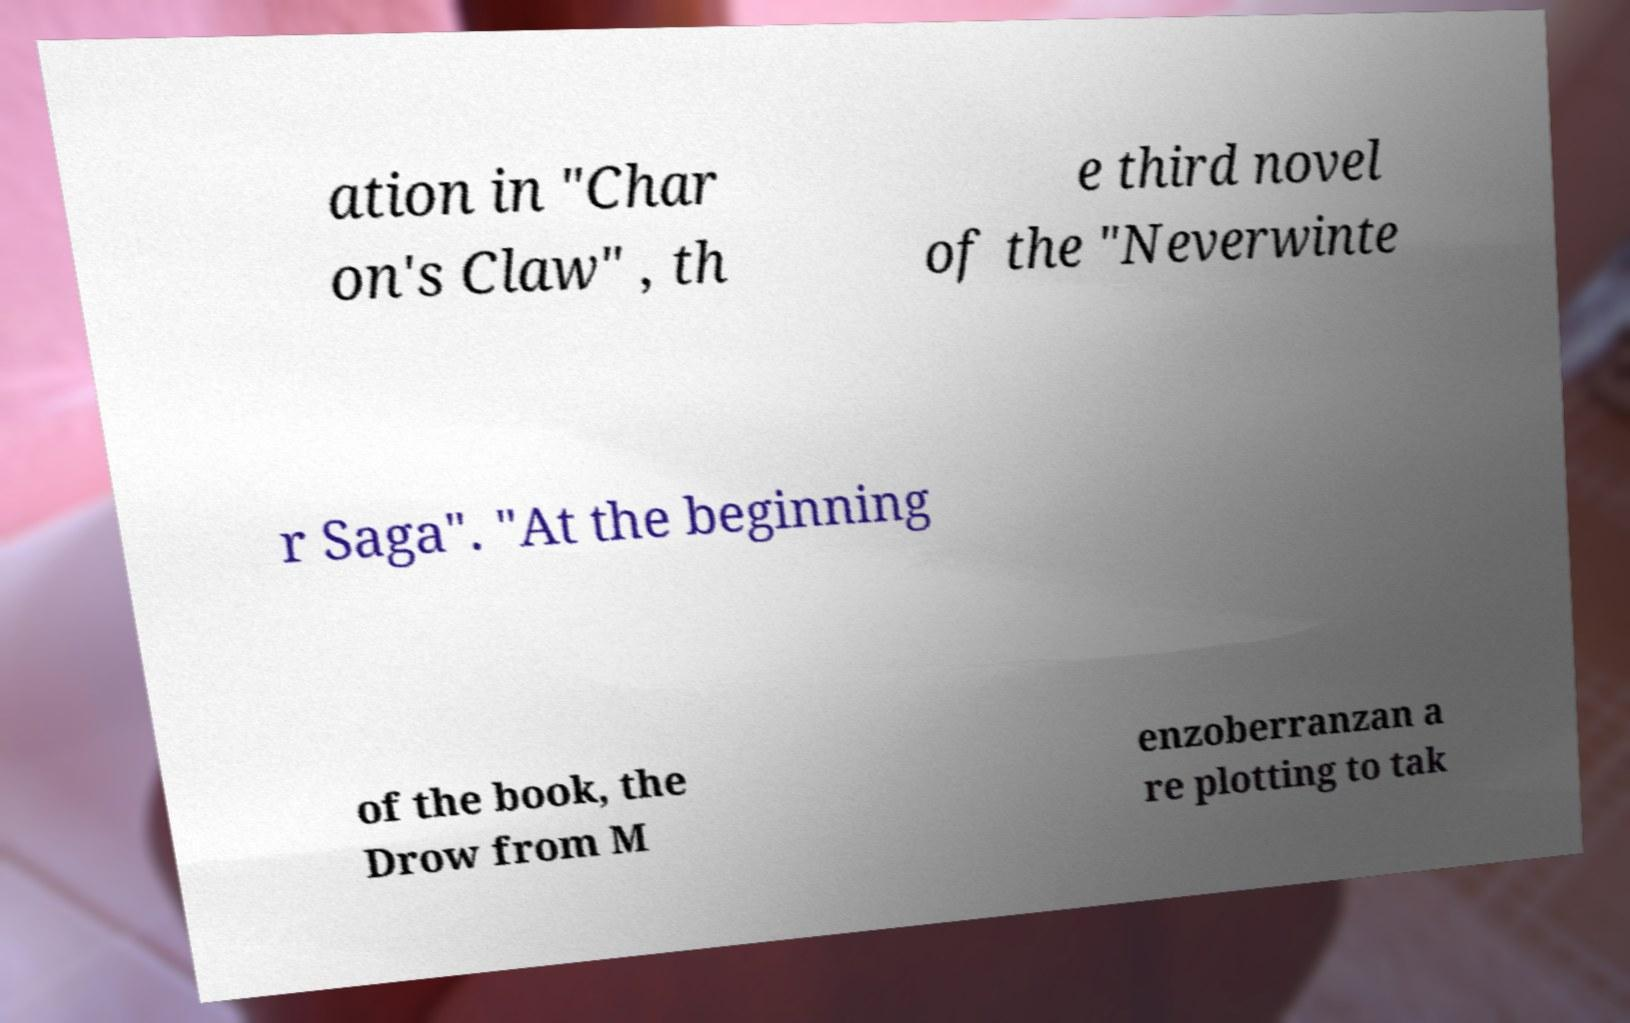What messages or text are displayed in this image? I need them in a readable, typed format. ation in "Char on's Claw" , th e third novel of the "Neverwinte r Saga". "At the beginning of the book, the Drow from M enzoberranzan a re plotting to tak 